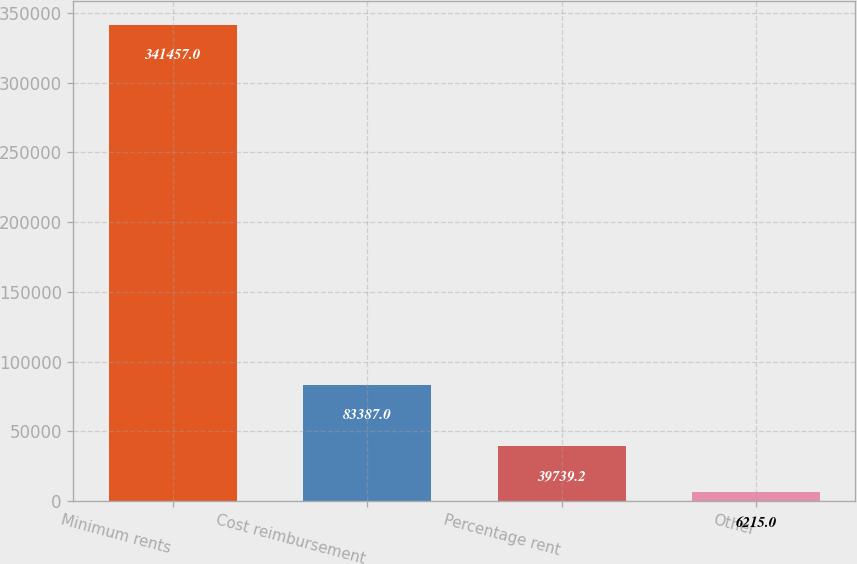<chart> <loc_0><loc_0><loc_500><loc_500><bar_chart><fcel>Minimum rents<fcel>Cost reimbursement<fcel>Percentage rent<fcel>Other<nl><fcel>341457<fcel>83387<fcel>39739.2<fcel>6215<nl></chart> 